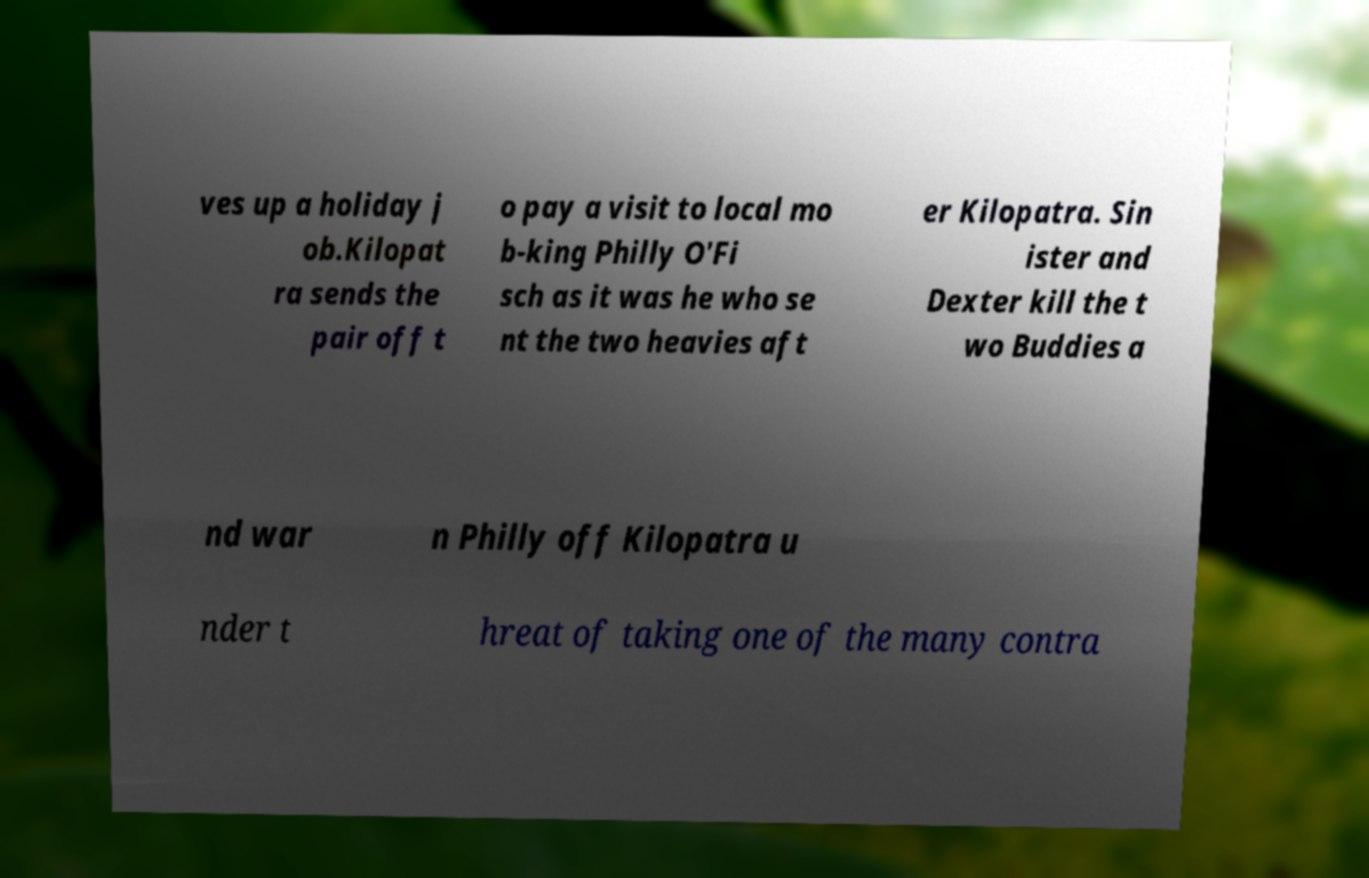For documentation purposes, I need the text within this image transcribed. Could you provide that? ves up a holiday j ob.Kilopat ra sends the pair off t o pay a visit to local mo b-king Philly O'Fi sch as it was he who se nt the two heavies aft er Kilopatra. Sin ister and Dexter kill the t wo Buddies a nd war n Philly off Kilopatra u nder t hreat of taking one of the many contra 